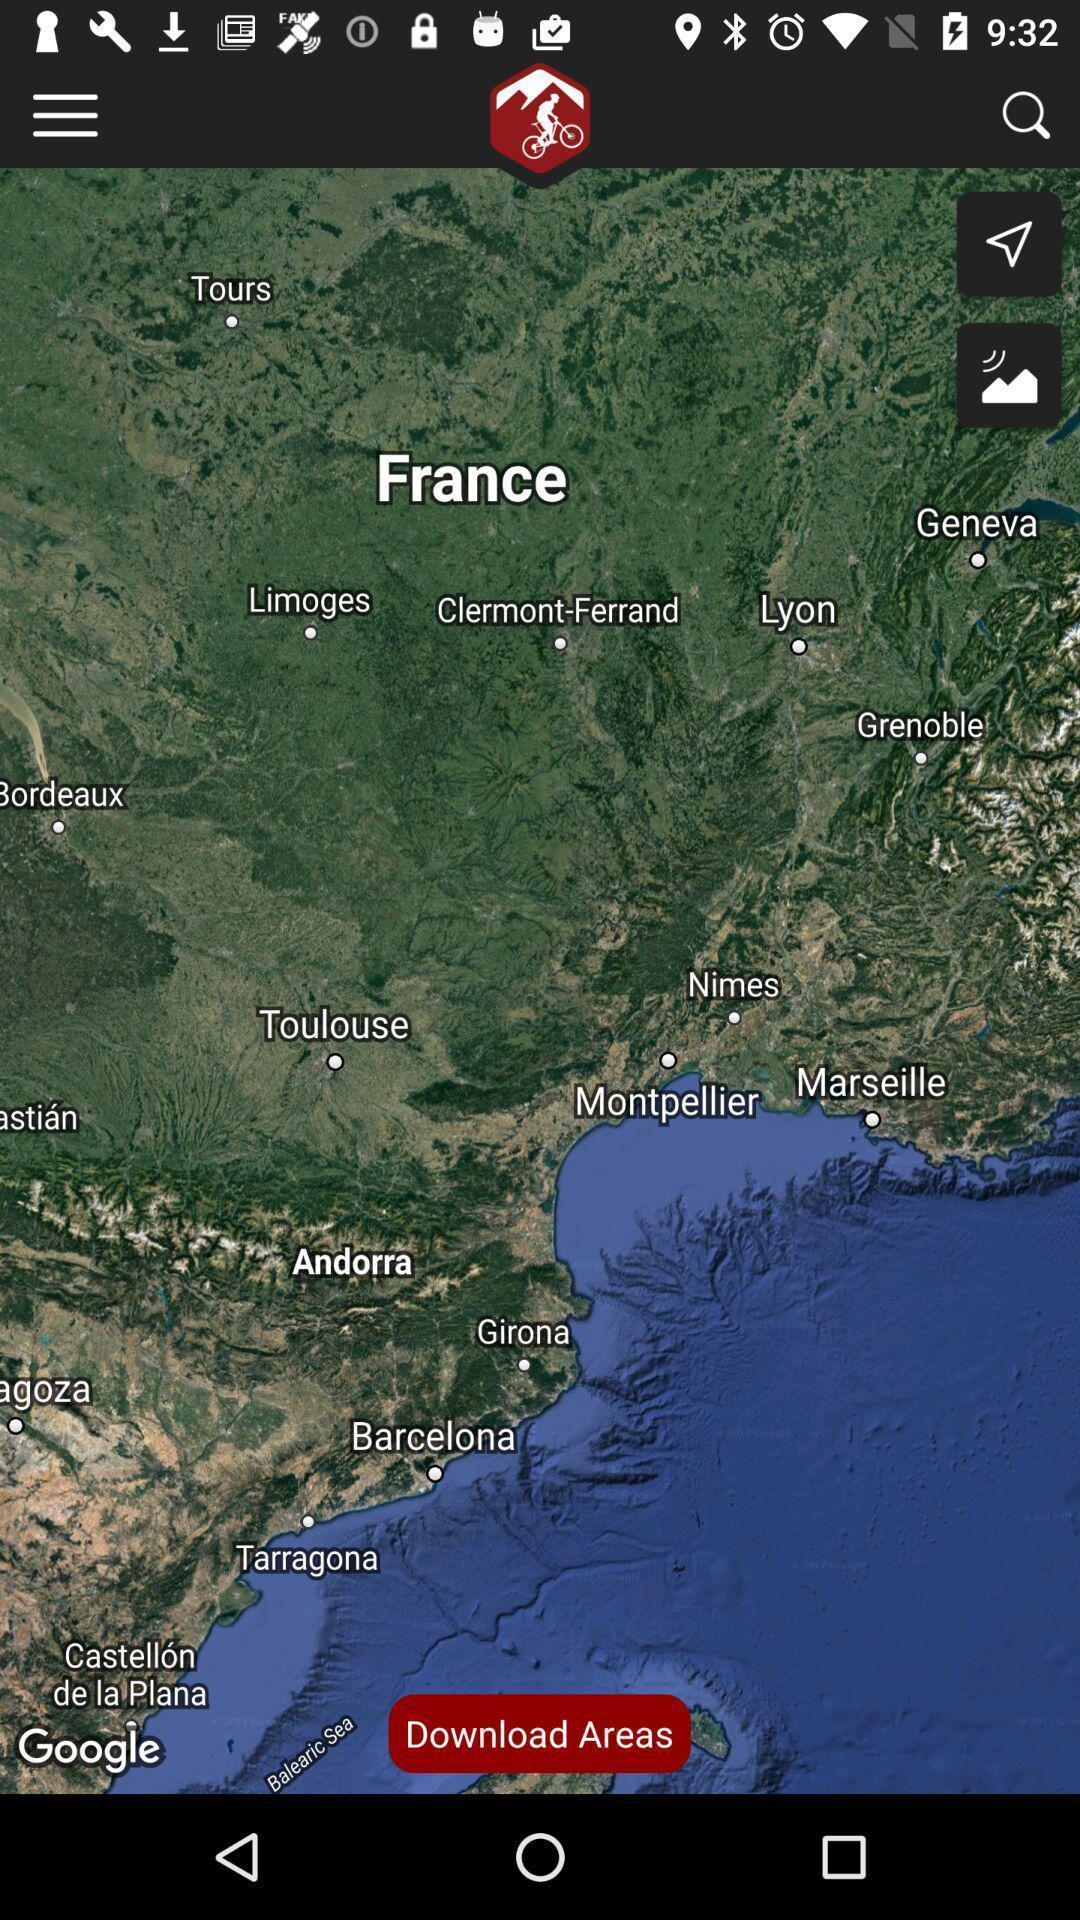Please provide a description for this image. Part of the france map in the application. 